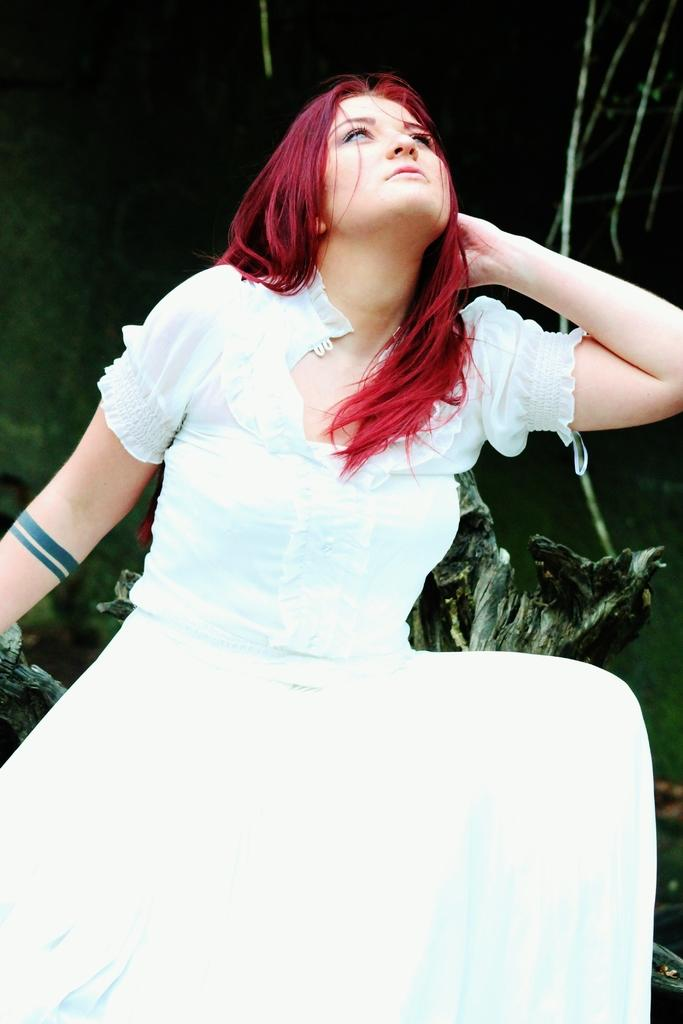Who is the main subject in the image? There is a girl in the image. What is the girl wearing? The girl is wearing a white dress. Can you describe the girl's hair color? The girl has red hair. What type of music can be heard playing in the background of the image? There is no music or audio present in the image, as it is a still photograph. 